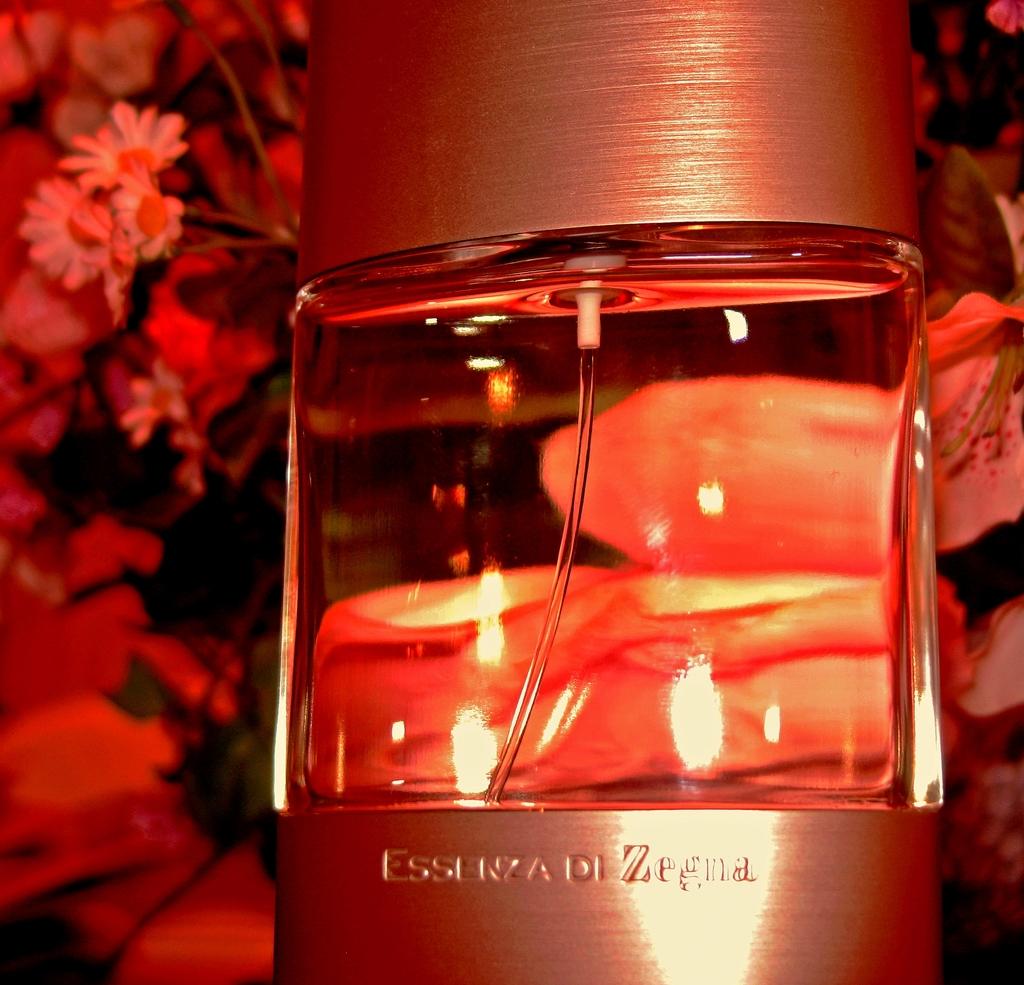What is the last word in the engraving?
Give a very brief answer. Zegna. What brand of perfume?
Make the answer very short. Essenza di zegna. 